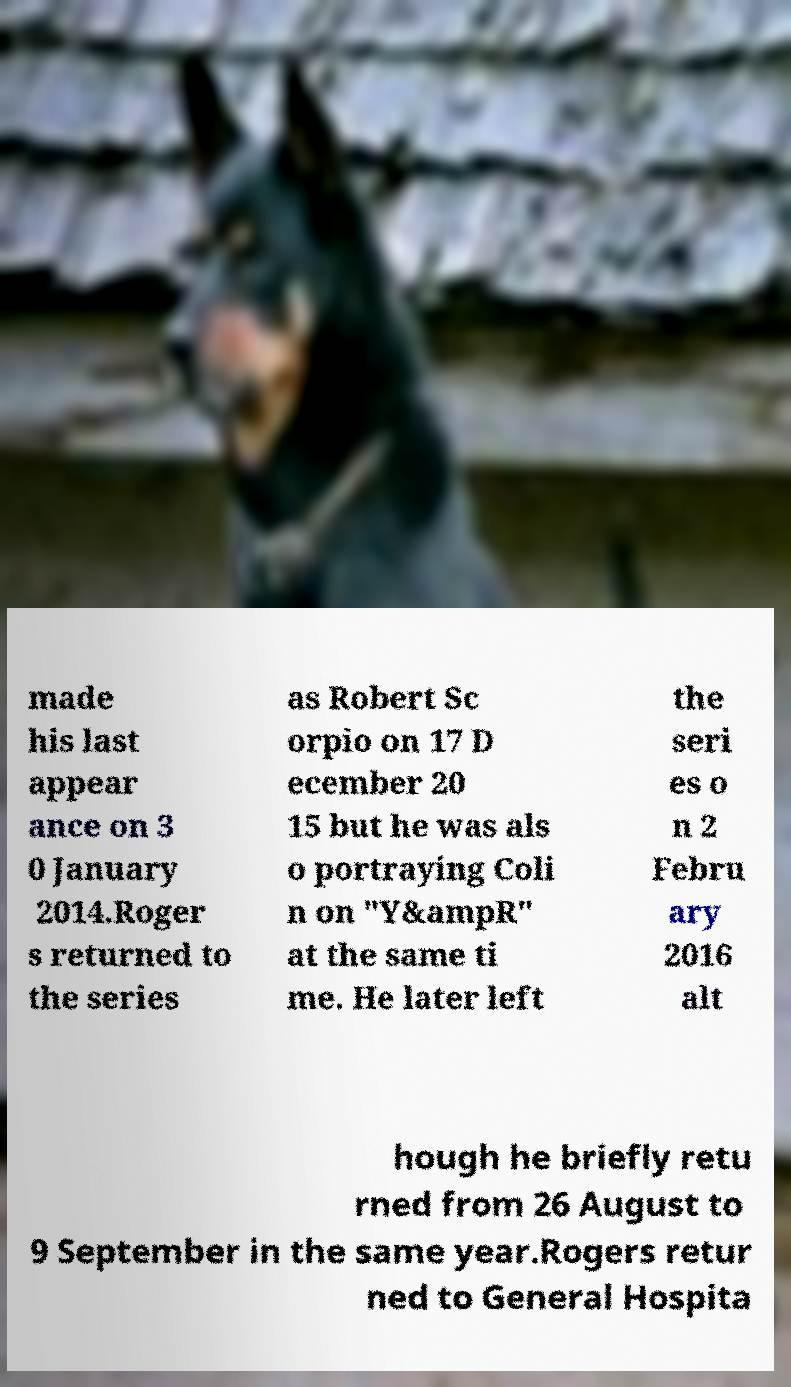There's text embedded in this image that I need extracted. Can you transcribe it verbatim? made his last appear ance on 3 0 January 2014.Roger s returned to the series as Robert Sc orpio on 17 D ecember 20 15 but he was als o portraying Coli n on "Y&ampR" at the same ti me. He later left the seri es o n 2 Febru ary 2016 alt hough he briefly retu rned from 26 August to 9 September in the same year.Rogers retur ned to General Hospita 